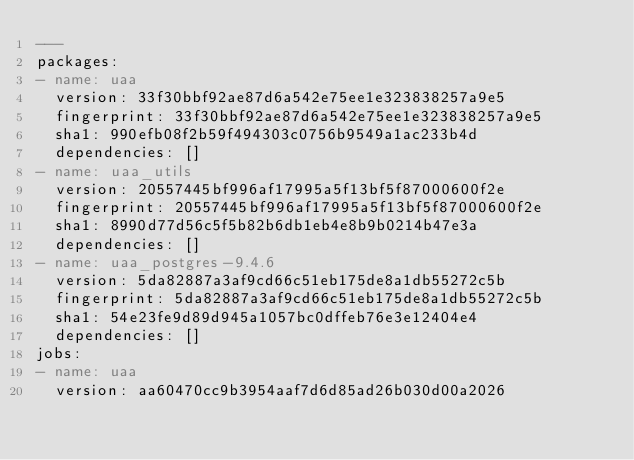Convert code to text. <code><loc_0><loc_0><loc_500><loc_500><_YAML_>---
packages:
- name: uaa
  version: 33f30bbf92ae87d6a542e75ee1e323838257a9e5
  fingerprint: 33f30bbf92ae87d6a542e75ee1e323838257a9e5
  sha1: 990efb08f2b59f494303c0756b9549a1ac233b4d
  dependencies: []
- name: uaa_utils
  version: 20557445bf996af17995a5f13bf5f87000600f2e
  fingerprint: 20557445bf996af17995a5f13bf5f87000600f2e
  sha1: 8990d77d56c5f5b82b6db1eb4e8b9b0214b47e3a
  dependencies: []
- name: uaa_postgres-9.4.6
  version: 5da82887a3af9cd66c51eb175de8a1db55272c5b
  fingerprint: 5da82887a3af9cd66c51eb175de8a1db55272c5b
  sha1: 54e23fe9d89d945a1057bc0dffeb76e3e12404e4
  dependencies: []
jobs:
- name: uaa
  version: aa60470cc9b3954aaf7d6d85ad26b030d00a2026</code> 